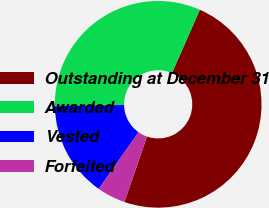Convert chart to OTSL. <chart><loc_0><loc_0><loc_500><loc_500><pie_chart><fcel>Outstanding at December 31<fcel>Awarded<fcel>Vested<fcel>Forfeited<nl><fcel>48.69%<fcel>31.91%<fcel>14.95%<fcel>4.45%<nl></chart> 